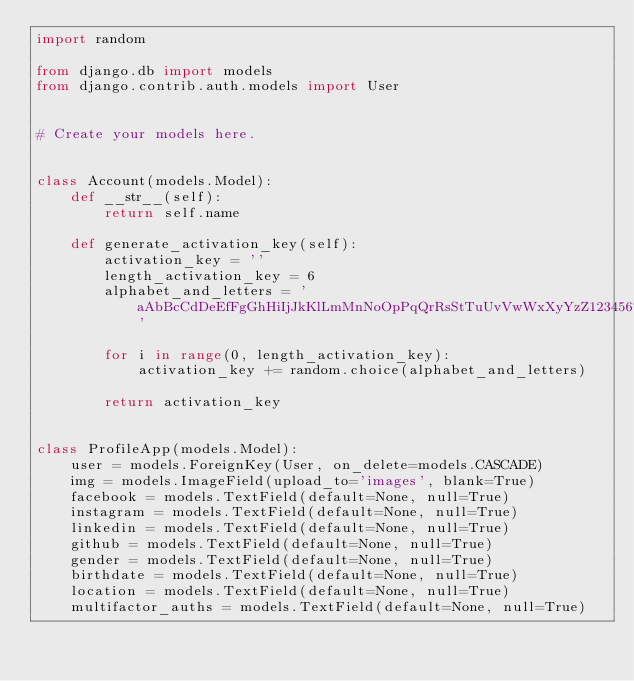<code> <loc_0><loc_0><loc_500><loc_500><_Python_>import random

from django.db import models
from django.contrib.auth.models import User


# Create your models here.


class Account(models.Model):
    def __str__(self):
        return self.name

    def generate_activation_key(self):
        activation_key = ''
        length_activation_key = 6
        alphabet_and_letters = 'aAbBcCdDeEfFgGhHiIjJkKlLmMnNoOpPqQrRsStTuUvVwWxXyYzZ1234567890'

        for i in range(0, length_activation_key):
            activation_key += random.choice(alphabet_and_letters)

        return activation_key


class ProfileApp(models.Model):
    user = models.ForeignKey(User, on_delete=models.CASCADE)
    img = models.ImageField(upload_to='images', blank=True)
    facebook = models.TextField(default=None, null=True)
    instagram = models.TextField(default=None, null=True)
    linkedin = models.TextField(default=None, null=True)
    github = models.TextField(default=None, null=True)
    gender = models.TextField(default=None, null=True)
    birthdate = models.TextField(default=None, null=True)
    location = models.TextField(default=None, null=True)
    multifactor_auths = models.TextField(default=None, null=True)
</code> 